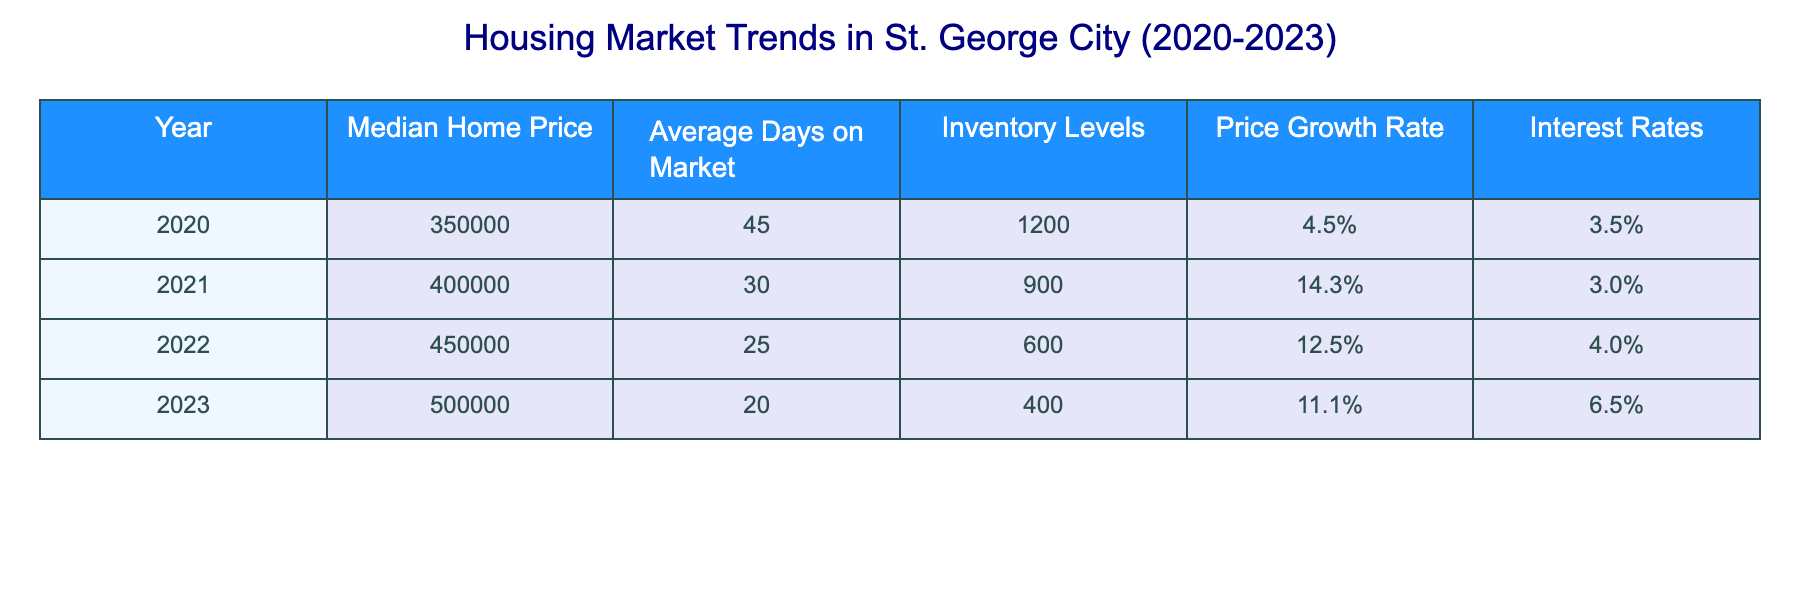What's the median home price in 2021? The table shows that the median home price for the year 2021 is $400,000.
Answer: $400,000 How many days did homes stay on the market on average in 2022? According to the table, the average days on market in 2022 is 25 days.
Answer: 25 days What was the price growth rate in 2023 compared to 2022? The price growth rate in 2023 is 11.1%, which is lower than 12.5% in 2022. Hence, the growth rate decreased.
Answer: Yes, it decreased What is the total inventory levels for the years 2020 and 2021 combined? By adding the inventory levels for 2020 (1200) and 2021 (900), the total is 1200 + 900 = 2100.
Answer: 2100 How does the interest rate in 2023 compare to the interest rate in 2021? The interest rate in 2021 was 3.0%, while in 2023 it is 6.5%. So, it increased significantly.
Answer: It increased What was the average price growth rate from 2020 to 2023? The price growth rates are 4.5%, 14.3%, 12.5%, and 11.1%. Adding these yields 42.4%, and dividing by 4 gives an average of 10.6%.
Answer: 10.6% How many inventory levels were there in 2020 compared to 2023? The inventory levels were 1200 in 2020 and 400 in 2023, which indicates a significant decrease.
Answer: 1200 vs 400 Which year had the highest median home price? The highest median home price recorded is in 2023 at $500,000.
Answer: 2023 In which year did homes sell the fastest on average? In 2023, homes had the lowest average days on market at 20 days, indicating they sold the fastest.
Answer: 2023 Was the average home price in 2022 higher than in 2021? The average home price in 2022 was $450,000, which is higher than the $400,000 in 2021.
Answer: Yes, it was higher 